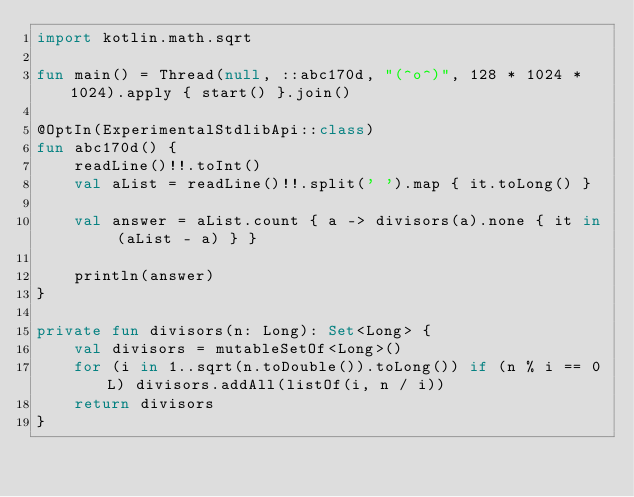<code> <loc_0><loc_0><loc_500><loc_500><_Kotlin_>import kotlin.math.sqrt

fun main() = Thread(null, ::abc170d, "(^o^)", 128 * 1024 * 1024).apply { start() }.join()

@OptIn(ExperimentalStdlibApi::class)
fun abc170d() {
    readLine()!!.toInt()
    val aList = readLine()!!.split(' ').map { it.toLong() }

    val answer = aList.count { a -> divisors(a).none { it in (aList - a) } }

    println(answer)
}

private fun divisors(n: Long): Set<Long> {
    val divisors = mutableSetOf<Long>()
    for (i in 1..sqrt(n.toDouble()).toLong()) if (n % i == 0L) divisors.addAll(listOf(i, n / i))
    return divisors
}
</code> 